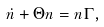Convert formula to latex. <formula><loc_0><loc_0><loc_500><loc_500>\dot { n } + \Theta n = n \Gamma ,</formula> 